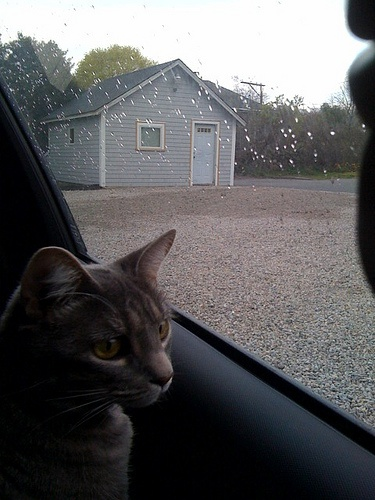Describe the objects in this image and their specific colors. I can see a cat in white, black, and gray tones in this image. 